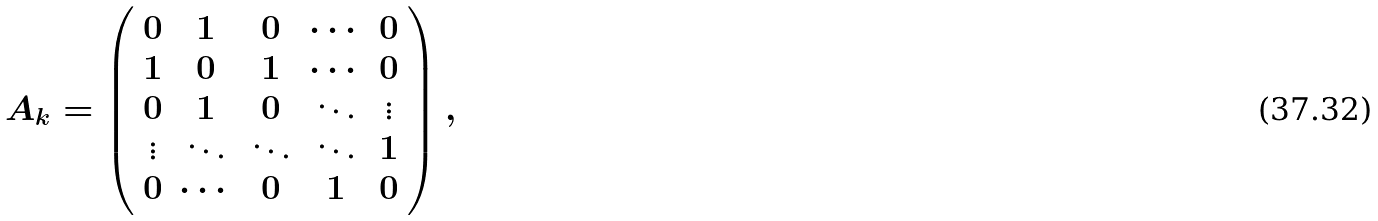Convert formula to latex. <formula><loc_0><loc_0><loc_500><loc_500>A _ { k } = \left ( \begin{array} { c c c c c } 0 & 1 & 0 & \cdots & 0 \\ 1 & 0 & 1 & \cdots & 0 \\ 0 & 1 & 0 & \ddots & \vdots \\ \vdots & \ddots & \ddots & \ddots & 1 \\ 0 & \cdots & 0 & 1 & 0 \end{array} \right ) ,</formula> 